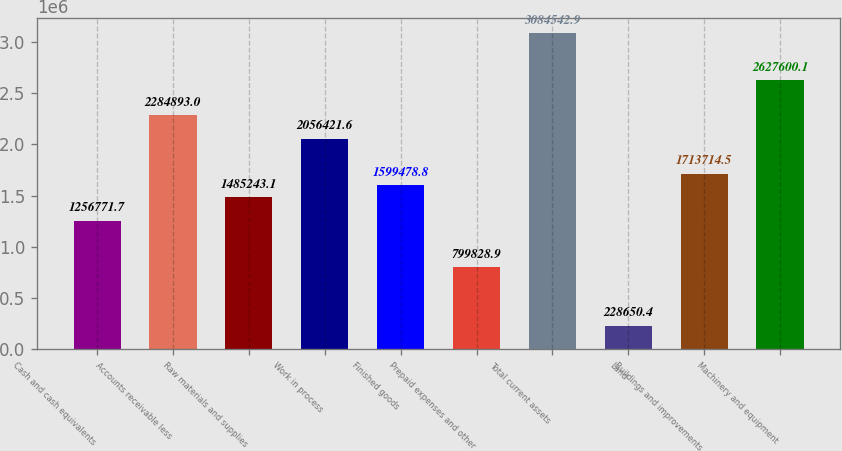Convert chart. <chart><loc_0><loc_0><loc_500><loc_500><bar_chart><fcel>Cash and cash equivalents<fcel>Accounts receivable less<fcel>Raw materials and supplies<fcel>Work in process<fcel>Finished goods<fcel>Prepaid expenses and other<fcel>Total current assets<fcel>Land<fcel>Buildings and improvements<fcel>Machinery and equipment<nl><fcel>1.25677e+06<fcel>2.28489e+06<fcel>1.48524e+06<fcel>2.05642e+06<fcel>1.59948e+06<fcel>799829<fcel>3.08454e+06<fcel>228650<fcel>1.71371e+06<fcel>2.6276e+06<nl></chart> 